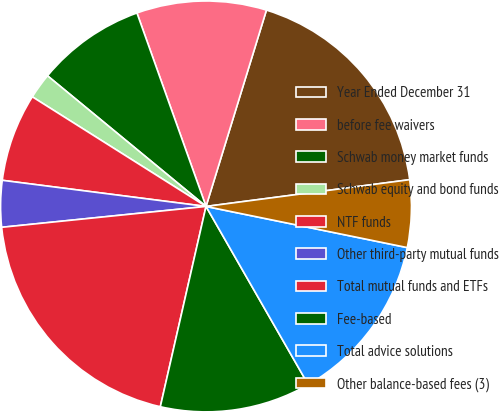<chart> <loc_0><loc_0><loc_500><loc_500><pie_chart><fcel>Year Ended December 31<fcel>before fee waivers<fcel>Schwab money market funds<fcel>Schwab equity and bond funds<fcel>NTF funds<fcel>Other third-party mutual funds<fcel>Total mutual funds and ETFs<fcel>Fee-based<fcel>Total advice solutions<fcel>Other balance-based fees (3)<nl><fcel>18.17%<fcel>10.21%<fcel>8.57%<fcel>2.01%<fcel>6.93%<fcel>3.65%<fcel>19.81%<fcel>11.86%<fcel>13.5%<fcel>5.29%<nl></chart> 